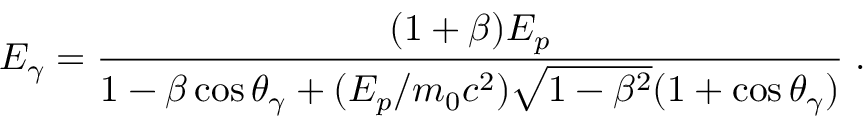<formula> <loc_0><loc_0><loc_500><loc_500>E _ { \gamma } = \frac { ( 1 + \beta ) E _ { p } } { 1 - \beta \cos \theta _ { \gamma } + ( E _ { p } / m _ { 0 } c ^ { 2 } ) \sqrt { 1 - \beta ^ { 2 } } ( 1 + \cos \theta _ { \gamma } ) } \, .</formula> 